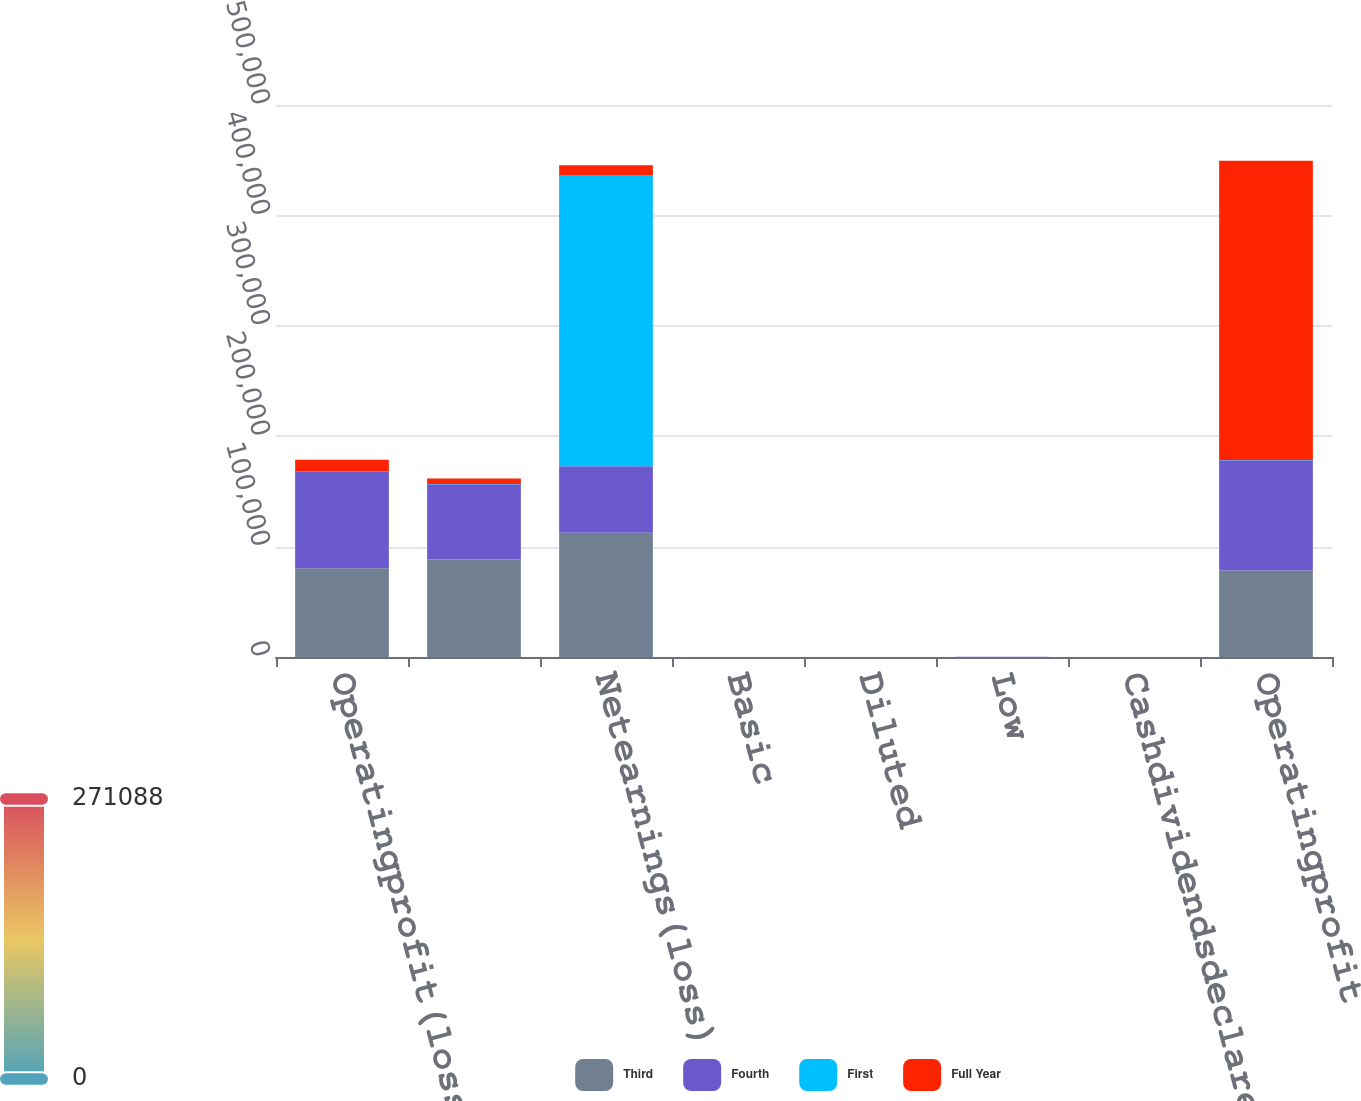Convert chart to OTSL. <chart><loc_0><loc_0><loc_500><loc_500><stacked_bar_chart><ecel><fcel>Operatingprofit(loss)<fcel>Unnamed: 2<fcel>Netearnings(loss)<fcel>Basic<fcel>Diluted<fcel>Low<fcel>Cashdividendsdeclared<fcel>Operatingprofit<nl><fcel>Third<fcel>80419<fcel>88388<fcel>112492<fcel>0.9<fcel>0.9<fcel>83.56<fcel>0.63<fcel>78343<nl><fcel>Fourth<fcel>87588<fcel>68124<fcel>60299<fcel>0.48<fcel>0.48<fcel>79<fcel>0.63<fcel>99984<nl><fcel>First<fcel>83.56<fcel>83.56<fcel>263861<fcel>2.08<fcel>2.06<fcel>91.7<fcel>0.63<fcel>83.56<nl><fcel>Full Year<fcel>10547<fcel>5128<fcel>8766<fcel>0.07<fcel>0.07<fcel>76.84<fcel>0.63<fcel>271088<nl></chart> 